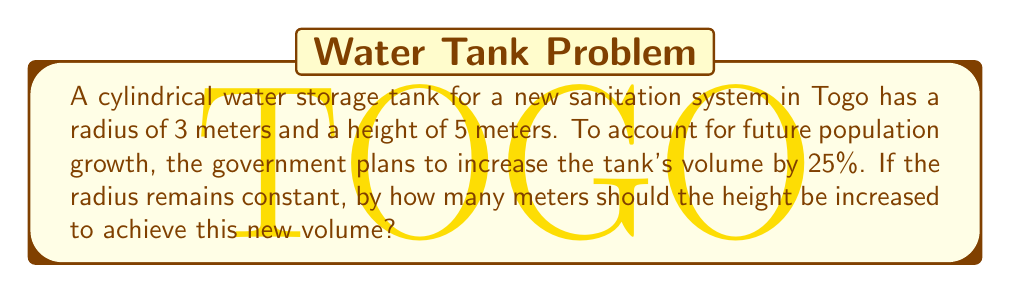Could you help me with this problem? Let's approach this step-by-step:

1) First, calculate the current volume of the cylindrical tank:
   $V_1 = \pi r^2 h$
   $V_1 = \pi \cdot 3^2 \cdot 5 = 45\pi$ cubic meters

2) The new volume will be 25% larger:
   $V_2 = V_1 + 25\% \cdot V_1 = 1.25V_1 = 1.25 \cdot 45\pi = 56.25\pi$ cubic meters

3) Now, we need to find the new height ($h_2$) that gives this volume:
   $V_2 = \pi r^2 h_2$
   $56.25\pi = \pi \cdot 3^2 \cdot h_2$

4) Solve for $h_2$:
   $h_2 = \frac{56.25\pi}{\pi \cdot 3^2} = \frac{56.25}{9} = 6.25$ meters

5) The increase in height is:
   $\Delta h = h_2 - h_1 = 6.25 - 5 = 1.25$ meters

Therefore, the height should be increased by 1.25 meters.
Answer: 1.25 meters 